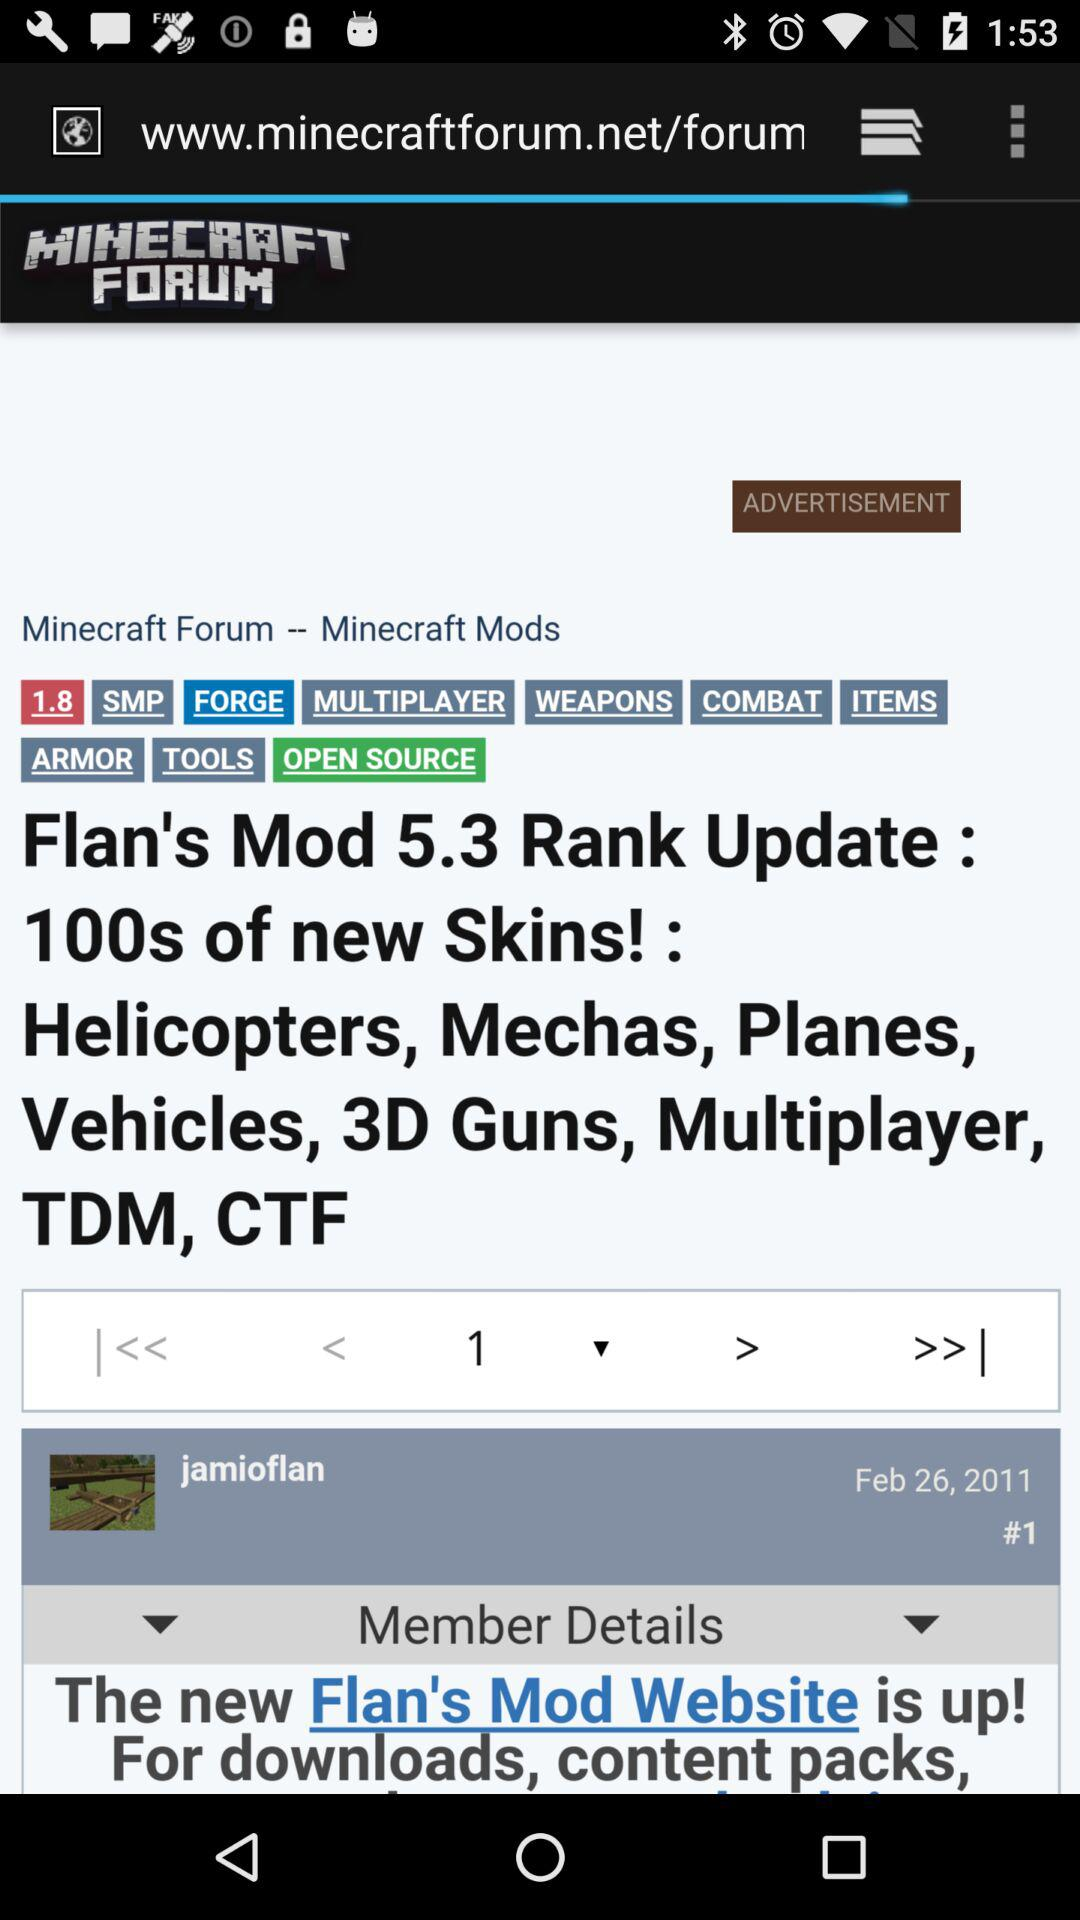What is the website name? The website name is "www.minecraftforum.net/forum". 